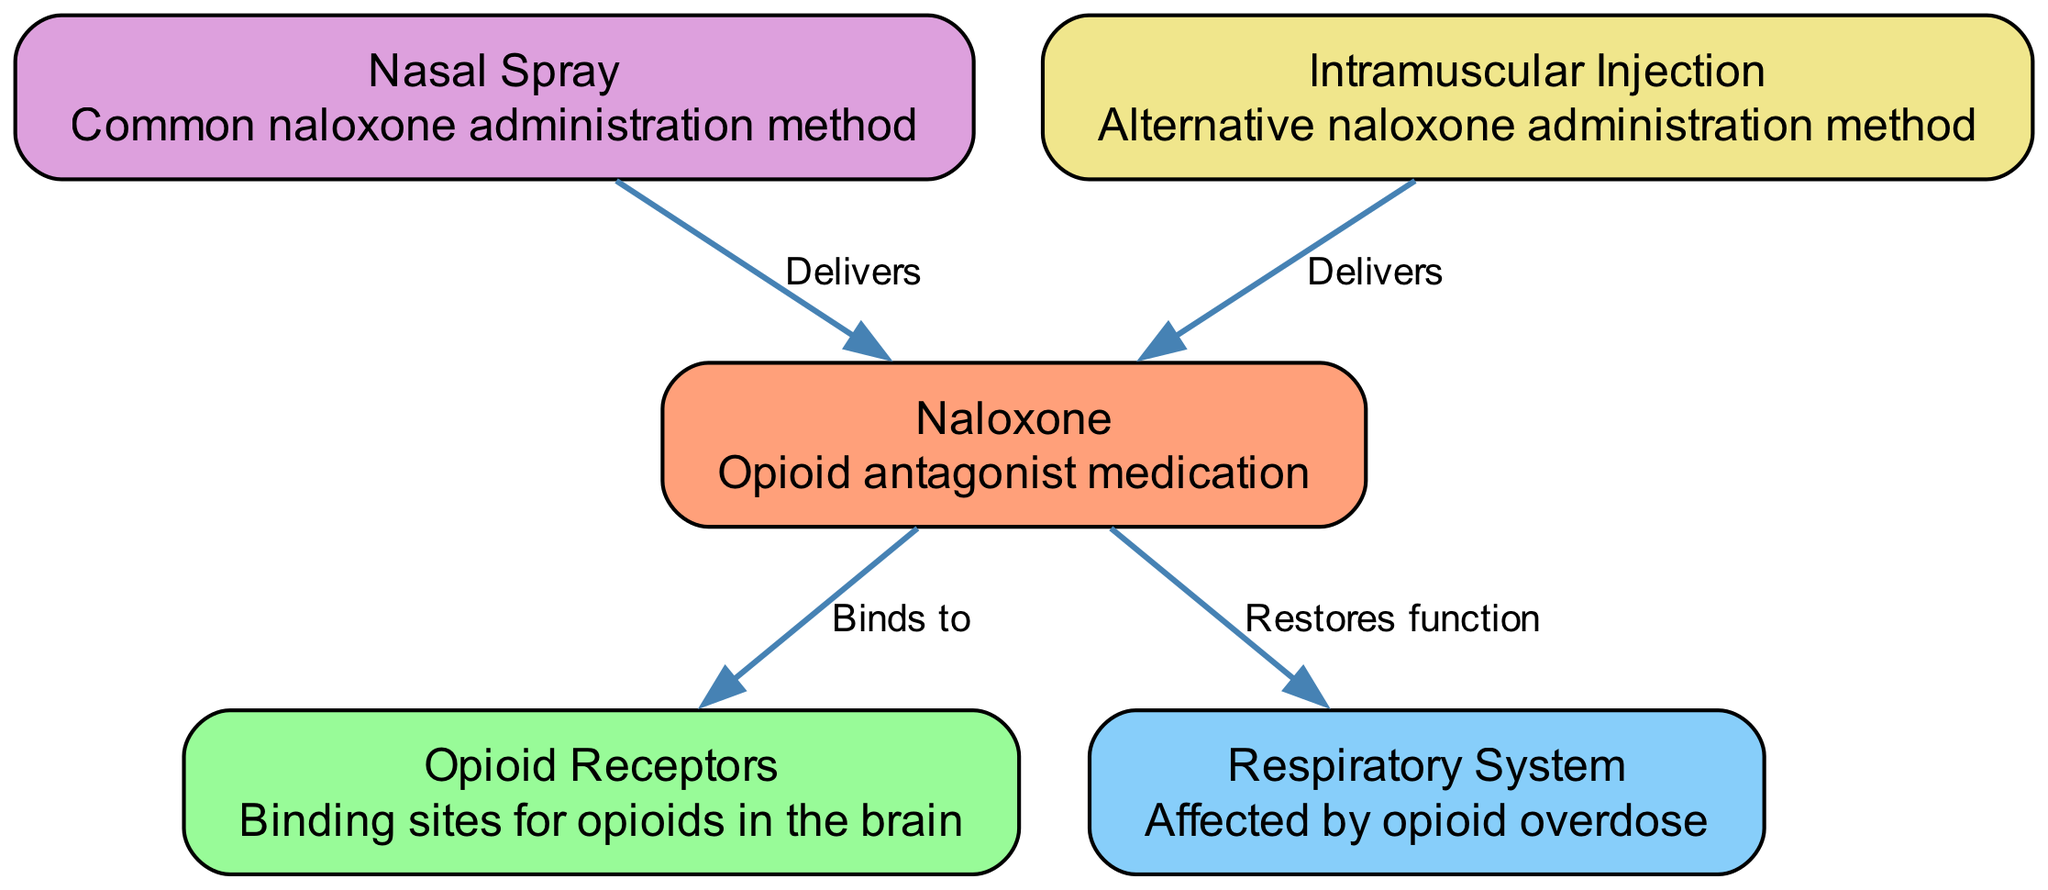What is the primary function of naloxone? The diagram describes naloxone as an "Opioid antagonist medication," indicating that its primary function is to antagonize or block the effects of opioids.
Answer: Opioid antagonist medication How is naloxone commonly administered? According to the diagram, one of the nodes states that "Nasal Spray" is a common method for administering naloxone, highlighting its prevalent use in emergencies.
Answer: Nasal Spray What does naloxone bind to? The diagram shows an edge indicating that naloxone "Binds to" the "Opioid Receptors," which confirms that naloxone specifically targets these sites in the brain.
Answer: Opioid Receptors What system does naloxone help restore function to? The diagram indicates that naloxone "Restores function" to the "Respiratory System," emphasizing its role in reversing the respiratory depression caused by opioid overdose.
Answer: Respiratory System How many methods of naloxone administration are depicted in the diagram? The diagram highlights two nodes for naloxone administration methods: "Nasal Spray" and "Intramuscular Injection," which confirms that there are two methods represented.
Answer: Two What is the connection between the nasal spray and naloxone? The diagram clearly illustrates a directional edge stating that the "Nasal Spray" "Delivers" naloxone, indicating the relationship and function of the delivery method.
Answer: Delivers How does naloxone affect the respiratory system during an opioid overdose? The diagram states that naloxone "Restores function" to the respiratory system, implying that it counteracts the respiratory failure caused by opioid effects.
Answer: Restores function Which administration method is an alternative to the nasal spray? The diagram provides "Intramuscular Injection" as another method of administering naloxone, thus serving as an alternative delivery method.
Answer: Intramuscular Injection Why is it important for naloxone to bind to opioid receptors? Binding to opioid receptors is critical as the diagram indicates that naloxone's action involves reversing the overdose effects by blocking those receptors, which opioids target.
Answer: To reverse overdose effects 